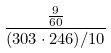<formula> <loc_0><loc_0><loc_500><loc_500>\frac { \frac { 9 } { 6 0 } } { ( 3 0 3 \cdot 2 4 6 ) / 1 0 }</formula> 